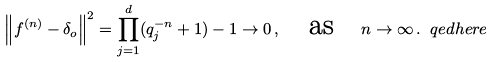Convert formula to latex. <formula><loc_0><loc_0><loc_500><loc_500>\left \| f ^ { ( n ) } - \delta _ { o } \right \| ^ { 2 } = \prod _ { j = 1 } ^ { d } ( q _ { j } ^ { - n } + 1 ) - 1 \rightarrow 0 \, , \quad \text {as} \quad n \to \infty \, . \ q e d h e r e</formula> 